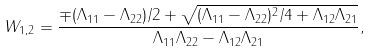Convert formula to latex. <formula><loc_0><loc_0><loc_500><loc_500>W _ { 1 , 2 } = \frac { \mp ( \Lambda _ { 1 1 } - \Lambda _ { 2 2 } ) / 2 + \sqrt { ( \Lambda _ { 1 1 } - \Lambda _ { 2 2 } ) ^ { 2 } / 4 + \Lambda _ { 1 2 } \Lambda _ { 2 1 } } } { \Lambda _ { 1 1 } \Lambda _ { 2 2 } - \Lambda _ { 1 2 } \Lambda _ { 2 1 } } ,</formula> 